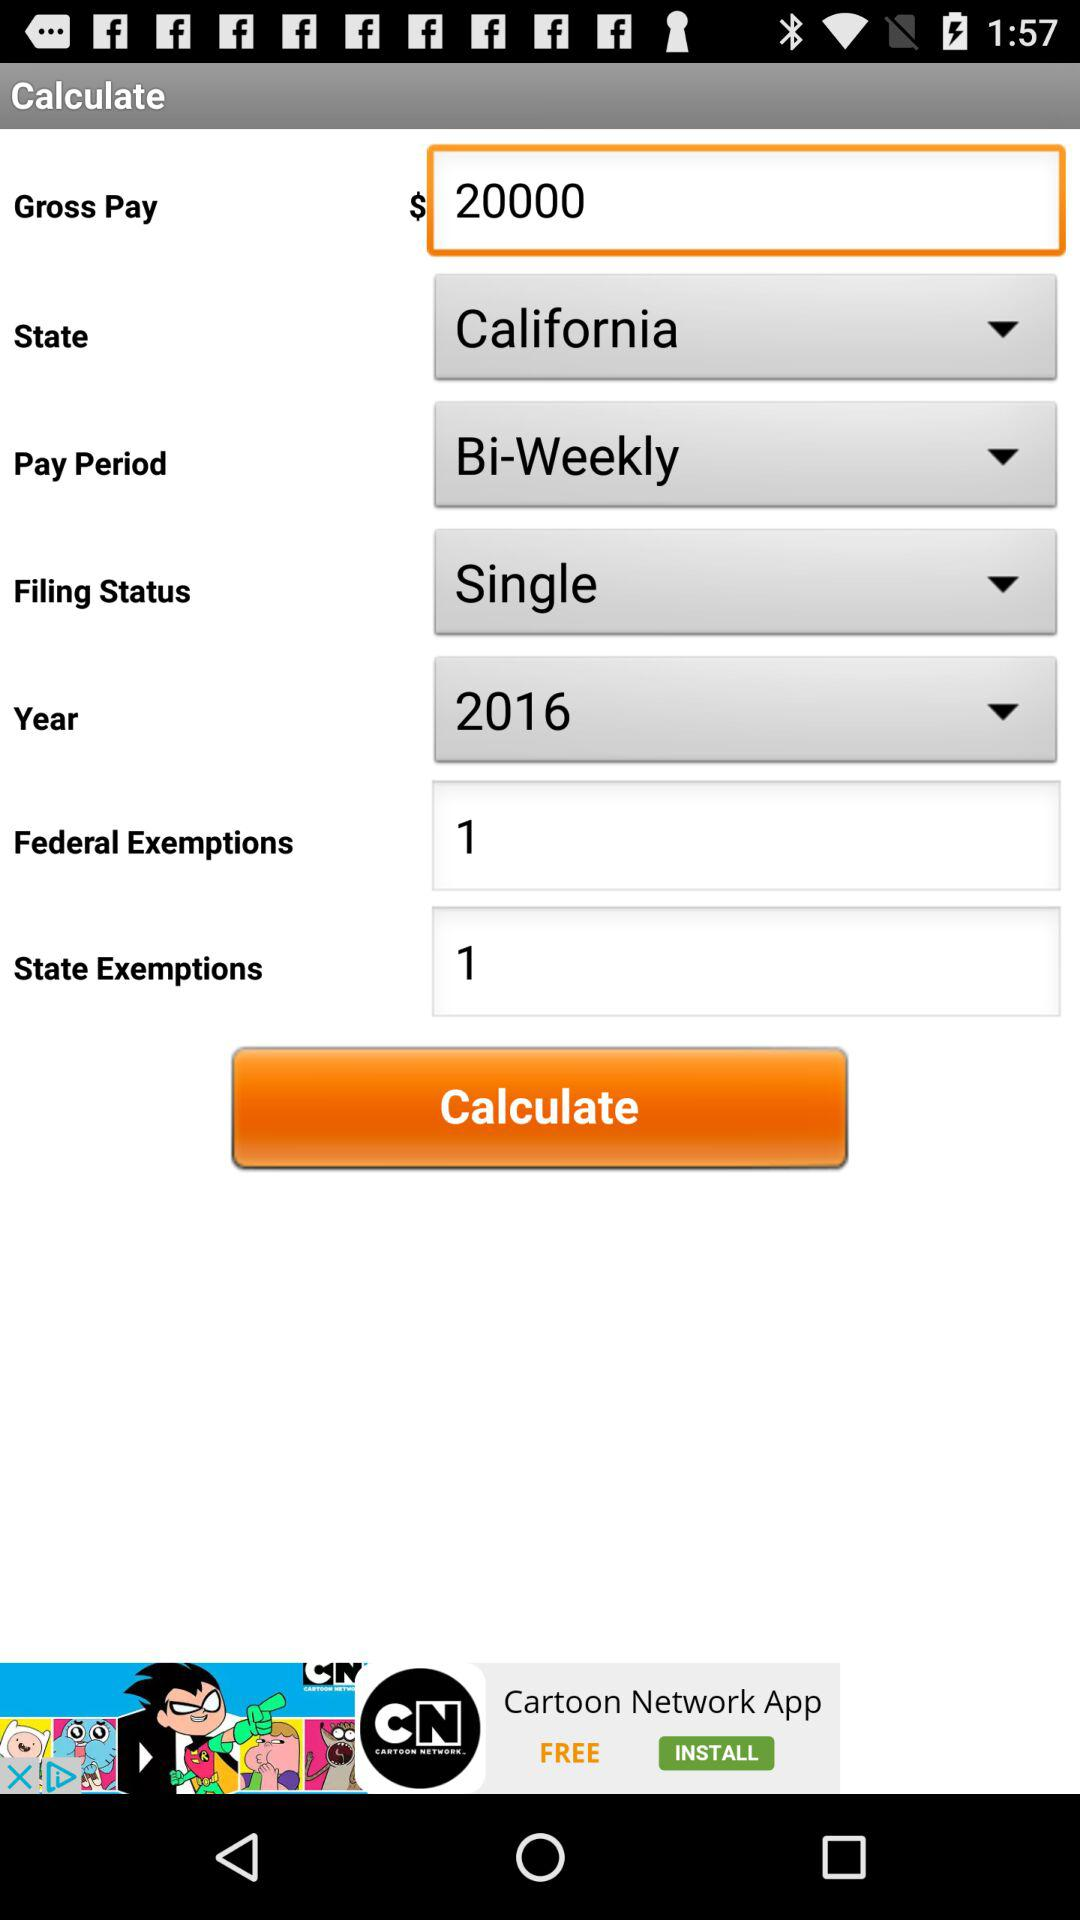What is the gross pay amount? The gross pay amount is $20000. 